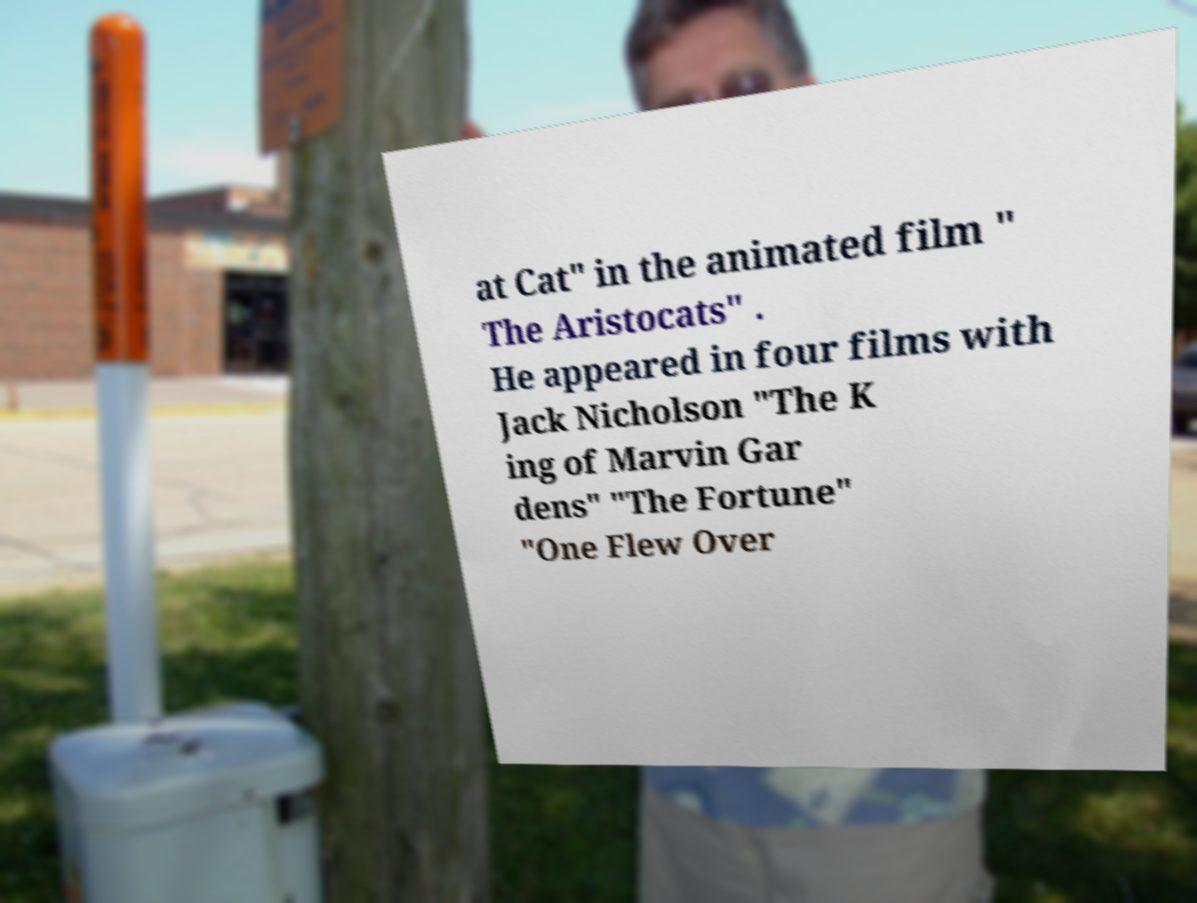For documentation purposes, I need the text within this image transcribed. Could you provide that? at Cat" in the animated film " The Aristocats" . He appeared in four films with Jack Nicholson "The K ing of Marvin Gar dens" "The Fortune" "One Flew Over 